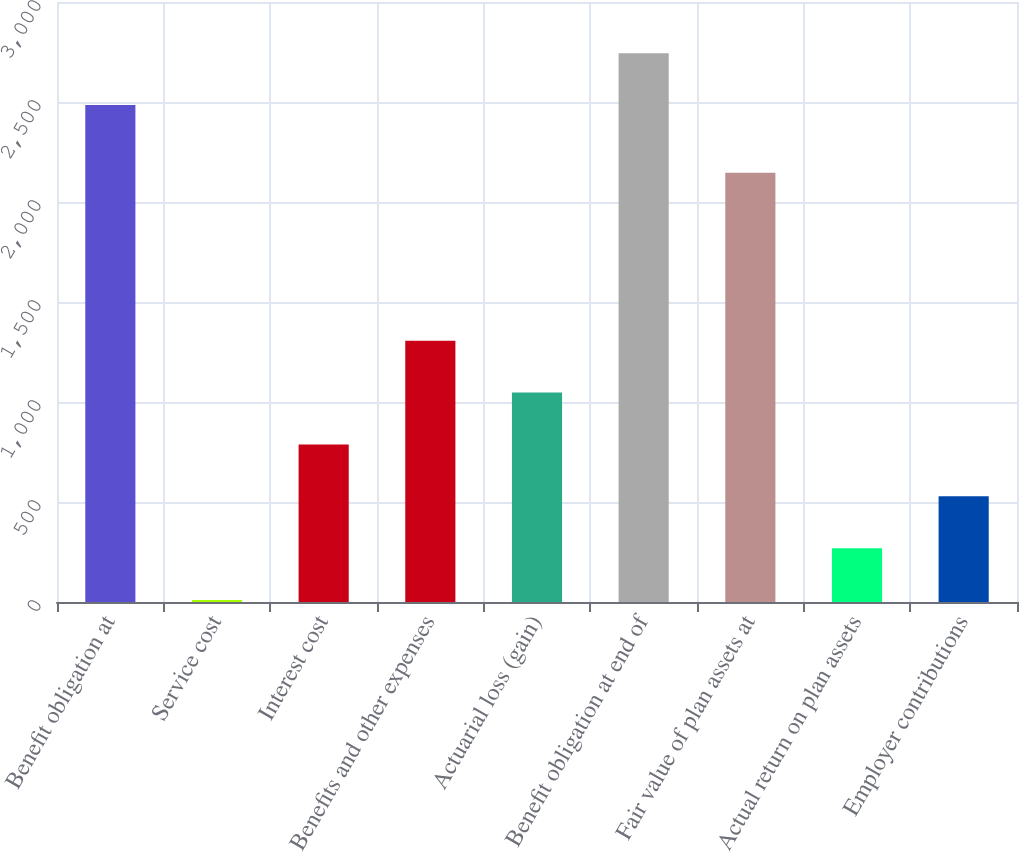<chart> <loc_0><loc_0><loc_500><loc_500><bar_chart><fcel>Benefit obligation at<fcel>Service cost<fcel>Interest cost<fcel>Benefits and other expenses<fcel>Actuarial loss (gain)<fcel>Benefit obligation at end of<fcel>Fair value of plan assets at<fcel>Actual return on plan assets<fcel>Employer contributions<nl><fcel>2484.7<fcel>9.6<fcel>787.89<fcel>1306.75<fcel>1047.32<fcel>2744.13<fcel>2145.73<fcel>269.03<fcel>528.46<nl></chart> 